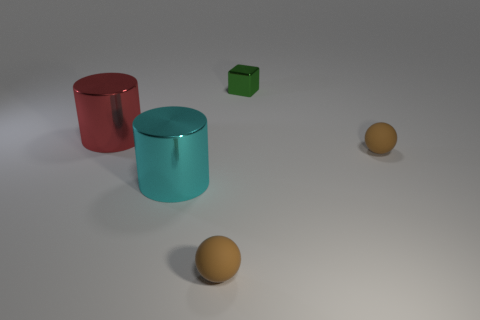Comparing the size of the green cube with other objects, is it larger, smaller or about the same size? The green cube is smaller in dimension than both the cylinders. Compared to the spheres, it's roughly similar in size although the volume would be larger due to its cube shape as opposed to the spherical shape of the spheres. 